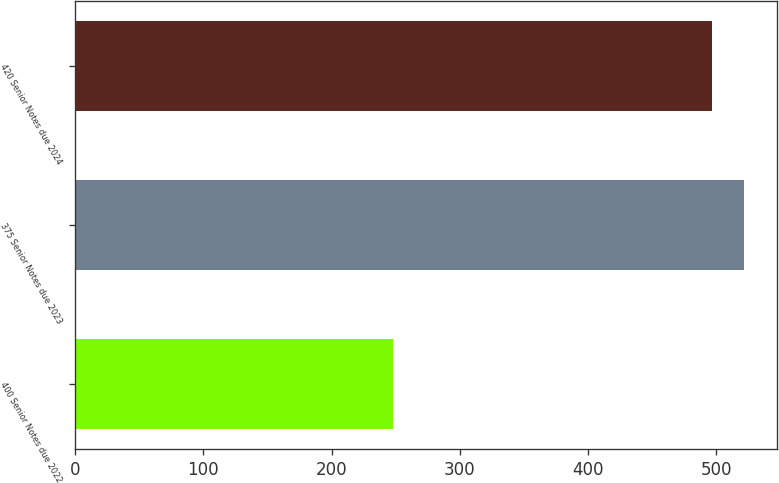Convert chart. <chart><loc_0><loc_0><loc_500><loc_500><bar_chart><fcel>400 Senior Notes due 2022<fcel>375 Senior Notes due 2023<fcel>420 Senior Notes due 2024<nl><fcel>247.6<fcel>521.65<fcel>496.7<nl></chart> 